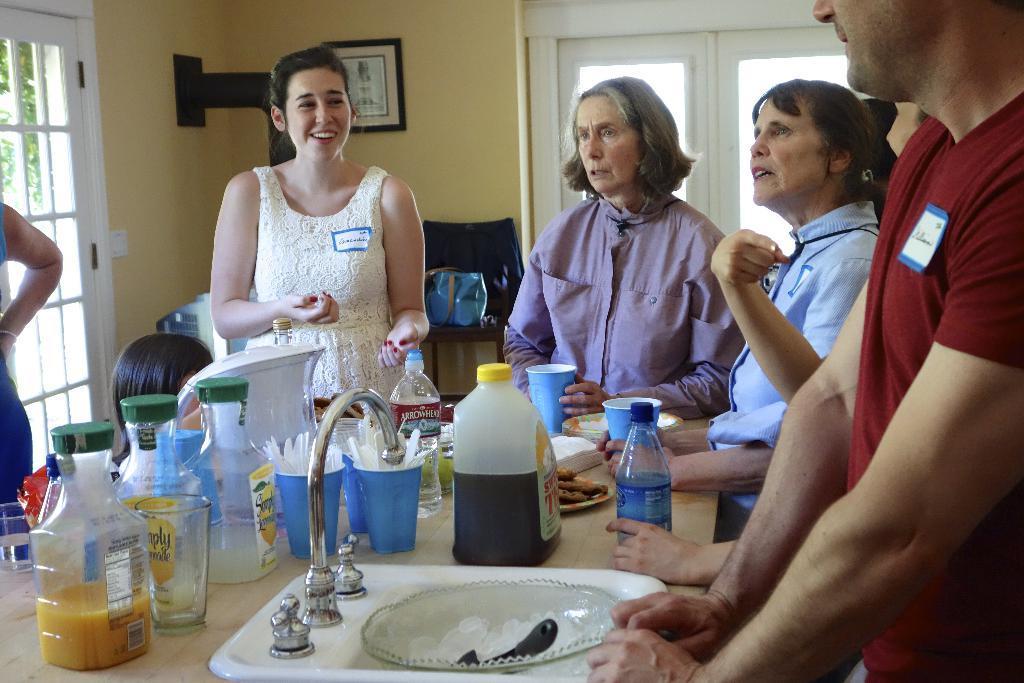Can you describe this image briefly? In the picture I can see a sink, tap, a bowl with ice cubes, some bottles, glasses and a few more things are placed on the table and we can see a person wearing maroon color T-shirt is on the right side of the image and we can see two women are standing and we can see a woman wearing white dress is smiling and standing near the table. In the background, we can see the glass windows, chair, photo frame on the wall and the doors. 